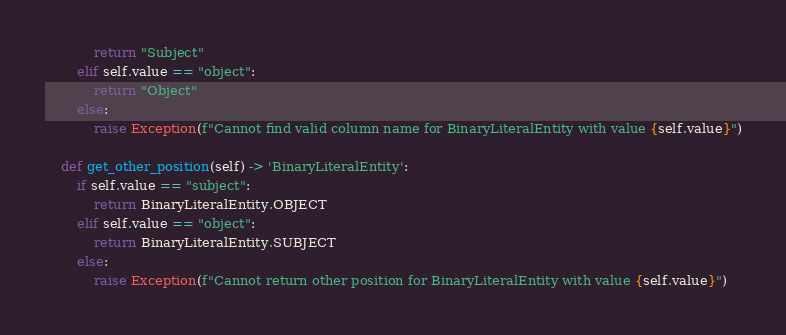<code> <loc_0><loc_0><loc_500><loc_500><_Python_>            return "Subject"
        elif self.value == "object":
            return "Object"
        else:
            raise Exception(f"Cannot find valid column name for BinaryLiteralEntity with value {self.value}")

    def get_other_position(self) -> 'BinaryLiteralEntity':
        if self.value == "subject":
            return BinaryLiteralEntity.OBJECT
        elif self.value == "object":
            return BinaryLiteralEntity.SUBJECT
        else:
            raise Exception(f"Cannot return other position for BinaryLiteralEntity with value {self.value}")
</code> 